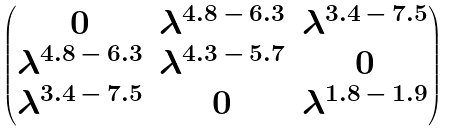<formula> <loc_0><loc_0><loc_500><loc_500>\begin{pmatrix} 0 & \lambda ^ { 4 . 8 \, - \, 6 . 3 } & \lambda ^ { 3 . 4 \, - \, 7 . 5 } \\ \lambda ^ { 4 . 8 \, - \, 6 . 3 } & \lambda ^ { 4 . 3 \, - \, 5 . 7 } & 0 \\ \lambda ^ { 3 . 4 \, - \, 7 . 5 } & 0 & \lambda ^ { 1 . 8 \, - \, 1 . 9 } \end{pmatrix}</formula> 